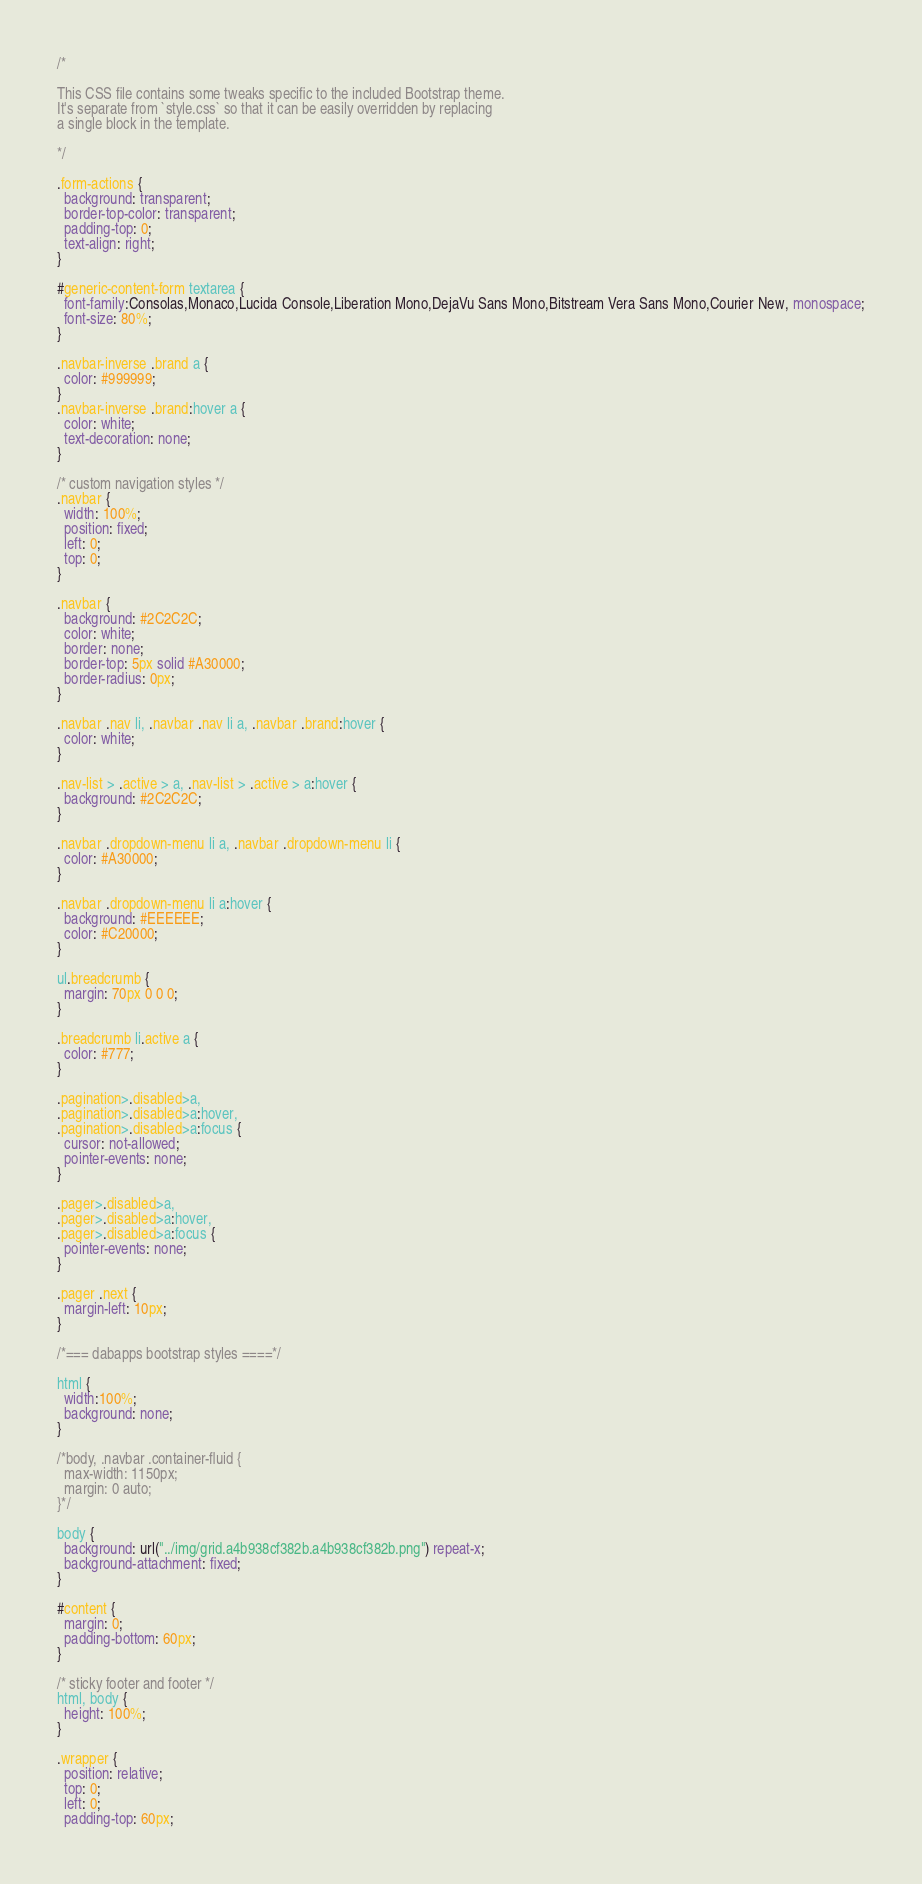<code> <loc_0><loc_0><loc_500><loc_500><_CSS_>/*

This CSS file contains some tweaks specific to the included Bootstrap theme.
It's separate from `style.css` so that it can be easily overridden by replacing
a single block in the template.

*/

.form-actions {
  background: transparent;
  border-top-color: transparent;
  padding-top: 0;
  text-align: right;
}

#generic-content-form textarea {
  font-family:Consolas,Monaco,Lucida Console,Liberation Mono,DejaVu Sans Mono,Bitstream Vera Sans Mono,Courier New, monospace;
  font-size: 80%;
}

.navbar-inverse .brand a {
  color: #999999;
}
.navbar-inverse .brand:hover a {
  color: white;
  text-decoration: none;
}

/* custom navigation styles */
.navbar {
  width: 100%;
  position: fixed;
  left: 0;
  top: 0;
}

.navbar {
  background: #2C2C2C;
  color: white;
  border: none;
  border-top: 5px solid #A30000;
  border-radius: 0px;
}

.navbar .nav li, .navbar .nav li a, .navbar .brand:hover {
  color: white;
}

.nav-list > .active > a, .nav-list > .active > a:hover {
  background: #2C2C2C;
}

.navbar .dropdown-menu li a, .navbar .dropdown-menu li {
  color: #A30000;
}

.navbar .dropdown-menu li a:hover {
  background: #EEEEEE;
  color: #C20000;
}

ul.breadcrumb {
  margin: 70px 0 0 0;
}

.breadcrumb li.active a {
  color: #777;
}

.pagination>.disabled>a,
.pagination>.disabled>a:hover,
.pagination>.disabled>a:focus {
  cursor: not-allowed;
  pointer-events: none;
}

.pager>.disabled>a,
.pager>.disabled>a:hover,
.pager>.disabled>a:focus {
  pointer-events: none;
}

.pager .next {
  margin-left: 10px;
}

/*=== dabapps bootstrap styles ====*/

html {
  width:100%;
  background: none;
}

/*body, .navbar .container-fluid {
  max-width: 1150px;
  margin: 0 auto;
}*/

body {
  background: url("../img/grid.a4b938cf382b.a4b938cf382b.png") repeat-x;
  background-attachment: fixed;
}

#content {
  margin: 0;
  padding-bottom: 60px;
}

/* sticky footer and footer */
html, body {
  height: 100%;
}

.wrapper {
  position: relative;
  top: 0;
  left: 0;
  padding-top: 60px;</code> 